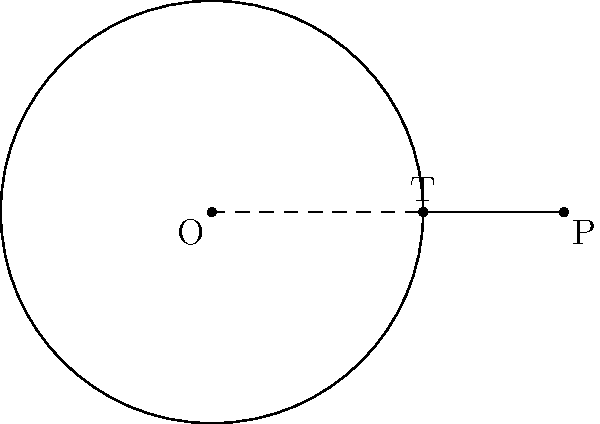In the diagram, $O$ is the center of the circle with radius $r = 3$ units. Point $P$ is outside the circle, and $PT$ is a tangent to the circle at point $T$. If the distance $OP = 5$ units, calculate the length of the tangent $PT$. How might this geometric principle relate to the reach of traditional evangelism methods compared to digital ones? Let's approach this step-by-step:

1) In a circle, a tangent line is perpendicular to the radius drawn to the point of tangency. This forms a right triangle OPT.

2) We can use the Pythagorean theorem in this right triangle:
   
   $OP^2 = OT^2 + PT^2$

3) We know that $OP = 5$ and $OT = r = 3$ (as $OT$ is a radius of the circle).

4) Let's call the length of the tangent $PT$ as $x$. Substituting these into the Pythagorean theorem:

   $5^2 = 3^2 + x^2$

5) Simplify:
   
   $25 = 9 + x^2$

6) Subtract 9 from both sides:
   
   $16 = x^2$

7) Take the square root of both sides:
   
   $x = 4$

Therefore, the length of the tangent $PT$ is 4 units.

This principle could be seen as analogous to the reach of evangelism methods. Traditional methods (represented by the radius) have a fixed, known reach. Digital methods (represented by the tangent) can extend beyond this traditional reach, potentially touching lives at a greater distance from the central point of the church.
Answer: 4 units 